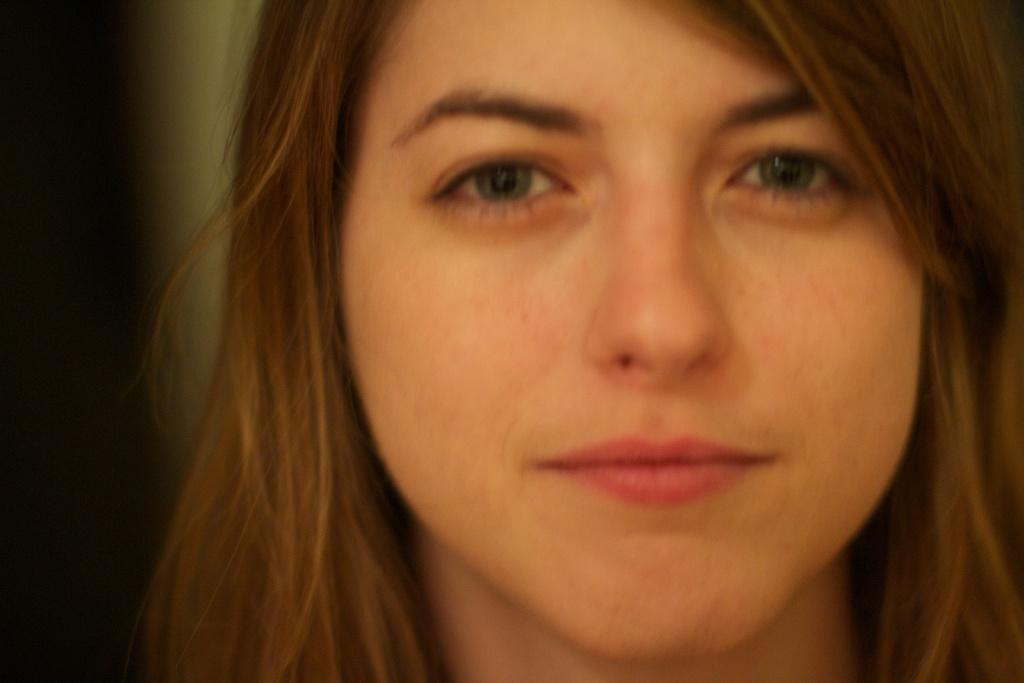How would you summarize this image in a sentence or two? In the center of the image we can see women. 